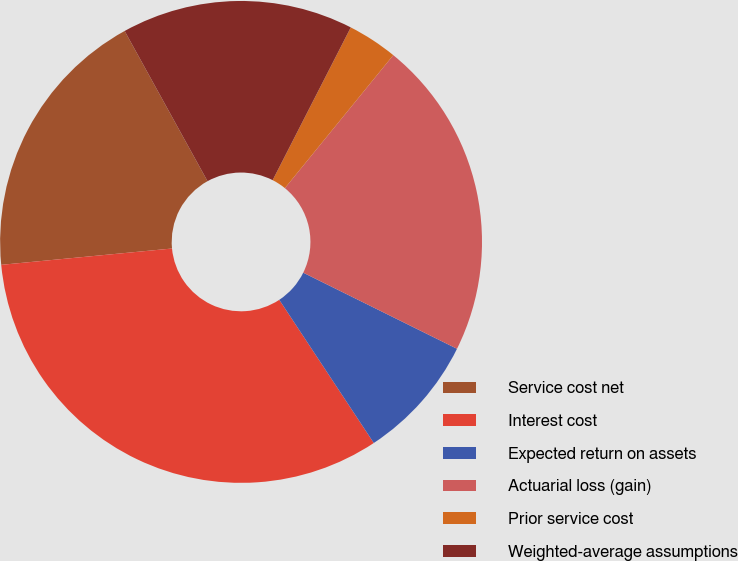Convert chart to OTSL. <chart><loc_0><loc_0><loc_500><loc_500><pie_chart><fcel>Service cost net<fcel>Interest cost<fcel>Expected return on assets<fcel>Actuarial loss (gain)<fcel>Prior service cost<fcel>Weighted-average assumptions<nl><fcel>18.49%<fcel>32.77%<fcel>8.4%<fcel>21.43%<fcel>3.36%<fcel>15.55%<nl></chart> 